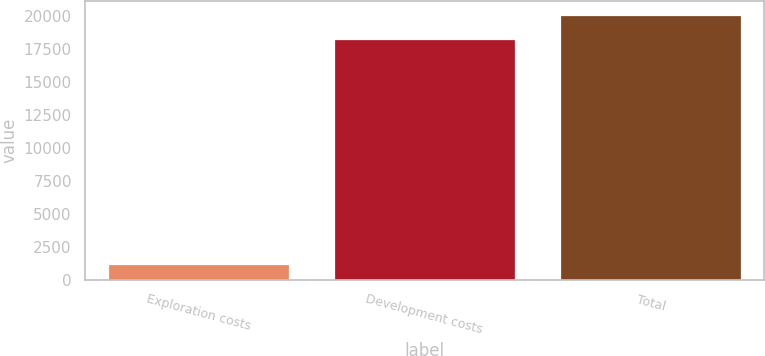Convert chart. <chart><loc_0><loc_0><loc_500><loc_500><bar_chart><fcel>Exploration costs<fcel>Development costs<fcel>Total<nl><fcel>1222<fcel>18274<fcel>20102<nl></chart> 